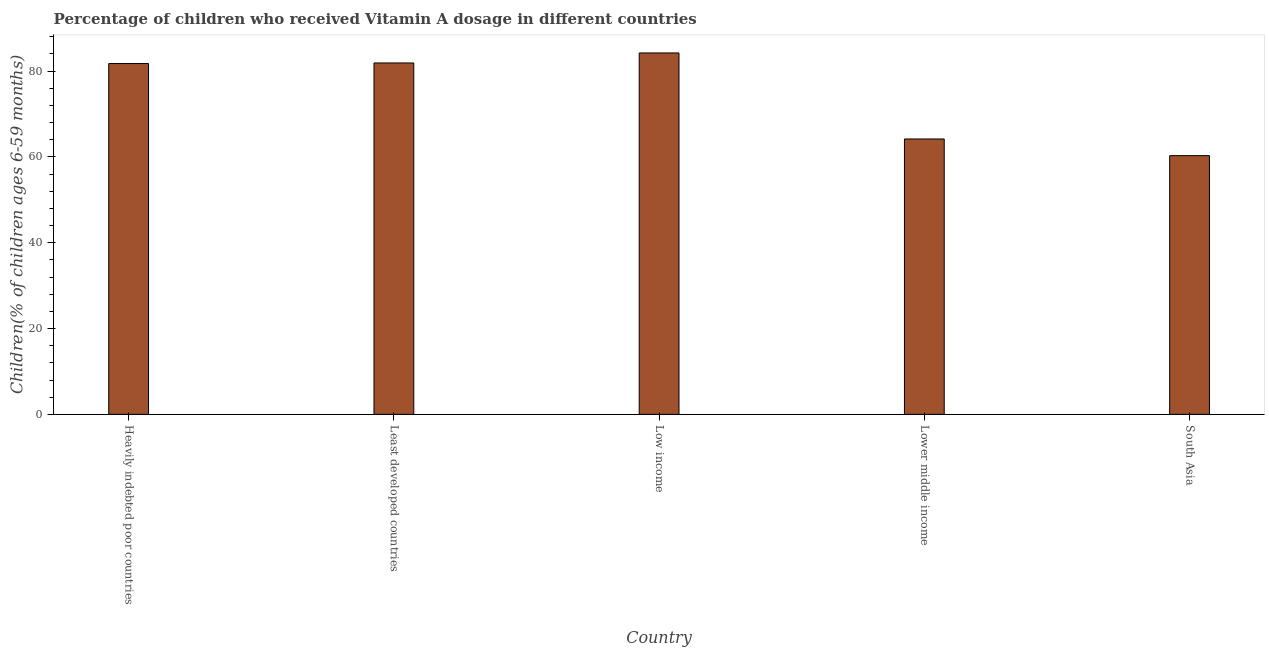Does the graph contain any zero values?
Your response must be concise. No. What is the title of the graph?
Your answer should be compact. Percentage of children who received Vitamin A dosage in different countries. What is the label or title of the Y-axis?
Provide a short and direct response. Children(% of children ages 6-59 months). What is the vitamin a supplementation coverage rate in Least developed countries?
Provide a succinct answer. 81.89. Across all countries, what is the maximum vitamin a supplementation coverage rate?
Offer a terse response. 84.22. Across all countries, what is the minimum vitamin a supplementation coverage rate?
Your response must be concise. 60.29. In which country was the vitamin a supplementation coverage rate maximum?
Ensure brevity in your answer.  Low income. What is the sum of the vitamin a supplementation coverage rate?
Make the answer very short. 372.33. What is the difference between the vitamin a supplementation coverage rate in Least developed countries and South Asia?
Give a very brief answer. 21.59. What is the average vitamin a supplementation coverage rate per country?
Give a very brief answer. 74.47. What is the median vitamin a supplementation coverage rate?
Give a very brief answer. 81.75. In how many countries, is the vitamin a supplementation coverage rate greater than 28 %?
Your answer should be compact. 5. What is the ratio of the vitamin a supplementation coverage rate in Least developed countries to that in Lower middle income?
Ensure brevity in your answer.  1.28. Is the difference between the vitamin a supplementation coverage rate in Least developed countries and Low income greater than the difference between any two countries?
Give a very brief answer. No. What is the difference between the highest and the second highest vitamin a supplementation coverage rate?
Give a very brief answer. 2.33. What is the difference between the highest and the lowest vitamin a supplementation coverage rate?
Your answer should be very brief. 23.93. How many countries are there in the graph?
Your answer should be very brief. 5. What is the difference between two consecutive major ticks on the Y-axis?
Ensure brevity in your answer.  20. Are the values on the major ticks of Y-axis written in scientific E-notation?
Your answer should be very brief. No. What is the Children(% of children ages 6-59 months) of Heavily indebted poor countries?
Your response must be concise. 81.75. What is the Children(% of children ages 6-59 months) of Least developed countries?
Keep it short and to the point. 81.89. What is the Children(% of children ages 6-59 months) of Low income?
Ensure brevity in your answer.  84.22. What is the Children(% of children ages 6-59 months) of Lower middle income?
Provide a succinct answer. 64.17. What is the Children(% of children ages 6-59 months) in South Asia?
Give a very brief answer. 60.29. What is the difference between the Children(% of children ages 6-59 months) in Heavily indebted poor countries and Least developed countries?
Your answer should be compact. -0.14. What is the difference between the Children(% of children ages 6-59 months) in Heavily indebted poor countries and Low income?
Provide a succinct answer. -2.47. What is the difference between the Children(% of children ages 6-59 months) in Heavily indebted poor countries and Lower middle income?
Offer a terse response. 17.58. What is the difference between the Children(% of children ages 6-59 months) in Heavily indebted poor countries and South Asia?
Your answer should be very brief. 21.46. What is the difference between the Children(% of children ages 6-59 months) in Least developed countries and Low income?
Make the answer very short. -2.33. What is the difference between the Children(% of children ages 6-59 months) in Least developed countries and Lower middle income?
Offer a terse response. 17.71. What is the difference between the Children(% of children ages 6-59 months) in Least developed countries and South Asia?
Offer a terse response. 21.6. What is the difference between the Children(% of children ages 6-59 months) in Low income and Lower middle income?
Your response must be concise. 20.05. What is the difference between the Children(% of children ages 6-59 months) in Low income and South Asia?
Offer a very short reply. 23.93. What is the difference between the Children(% of children ages 6-59 months) in Lower middle income and South Asia?
Ensure brevity in your answer.  3.88. What is the ratio of the Children(% of children ages 6-59 months) in Heavily indebted poor countries to that in Low income?
Your response must be concise. 0.97. What is the ratio of the Children(% of children ages 6-59 months) in Heavily indebted poor countries to that in Lower middle income?
Make the answer very short. 1.27. What is the ratio of the Children(% of children ages 6-59 months) in Heavily indebted poor countries to that in South Asia?
Ensure brevity in your answer.  1.36. What is the ratio of the Children(% of children ages 6-59 months) in Least developed countries to that in Lower middle income?
Keep it short and to the point. 1.28. What is the ratio of the Children(% of children ages 6-59 months) in Least developed countries to that in South Asia?
Provide a short and direct response. 1.36. What is the ratio of the Children(% of children ages 6-59 months) in Low income to that in Lower middle income?
Your answer should be very brief. 1.31. What is the ratio of the Children(% of children ages 6-59 months) in Low income to that in South Asia?
Offer a terse response. 1.4. What is the ratio of the Children(% of children ages 6-59 months) in Lower middle income to that in South Asia?
Offer a terse response. 1.06. 